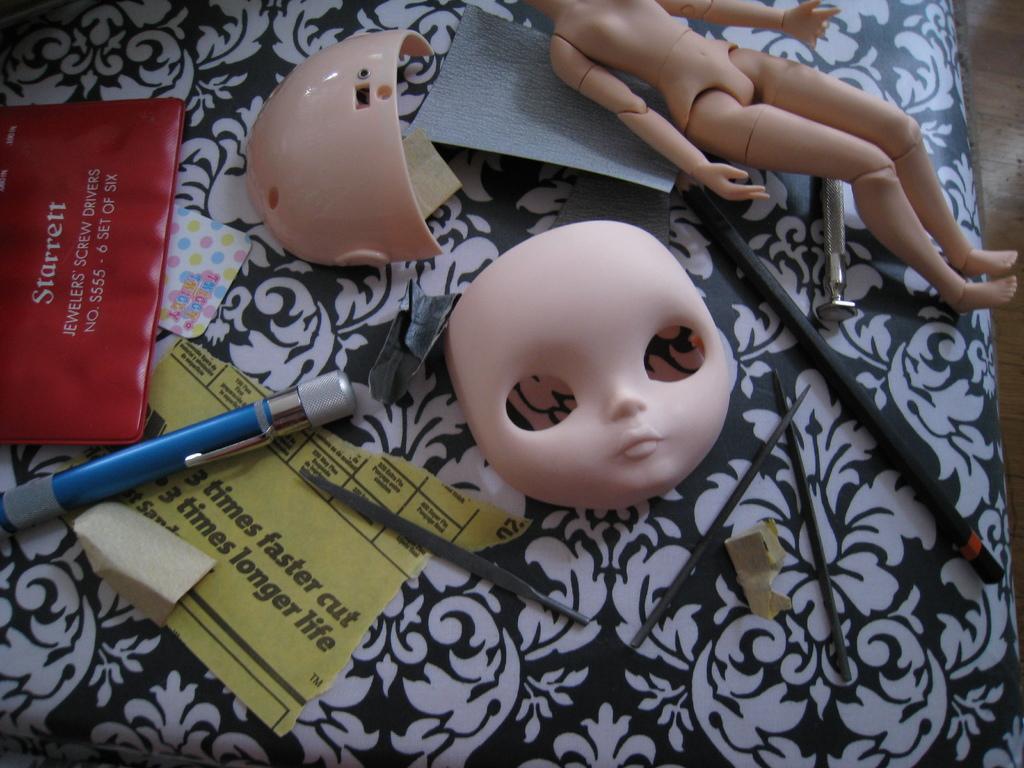How would you summarize this image in a sentence or two? In this image I can see the doll, pen, papers, few parts of doll and few objects on the black and white color surface. 